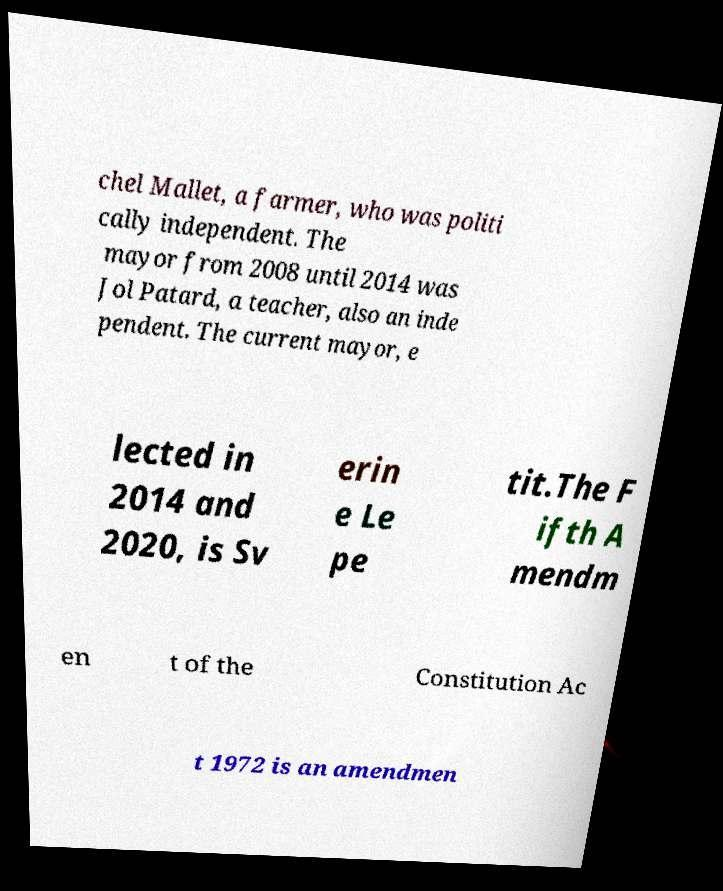Could you assist in decoding the text presented in this image and type it out clearly? chel Mallet, a farmer, who was politi cally independent. The mayor from 2008 until 2014 was Jol Patard, a teacher, also an inde pendent. The current mayor, e lected in 2014 and 2020, is Sv erin e Le pe tit.The F ifth A mendm en t of the Constitution Ac t 1972 is an amendmen 